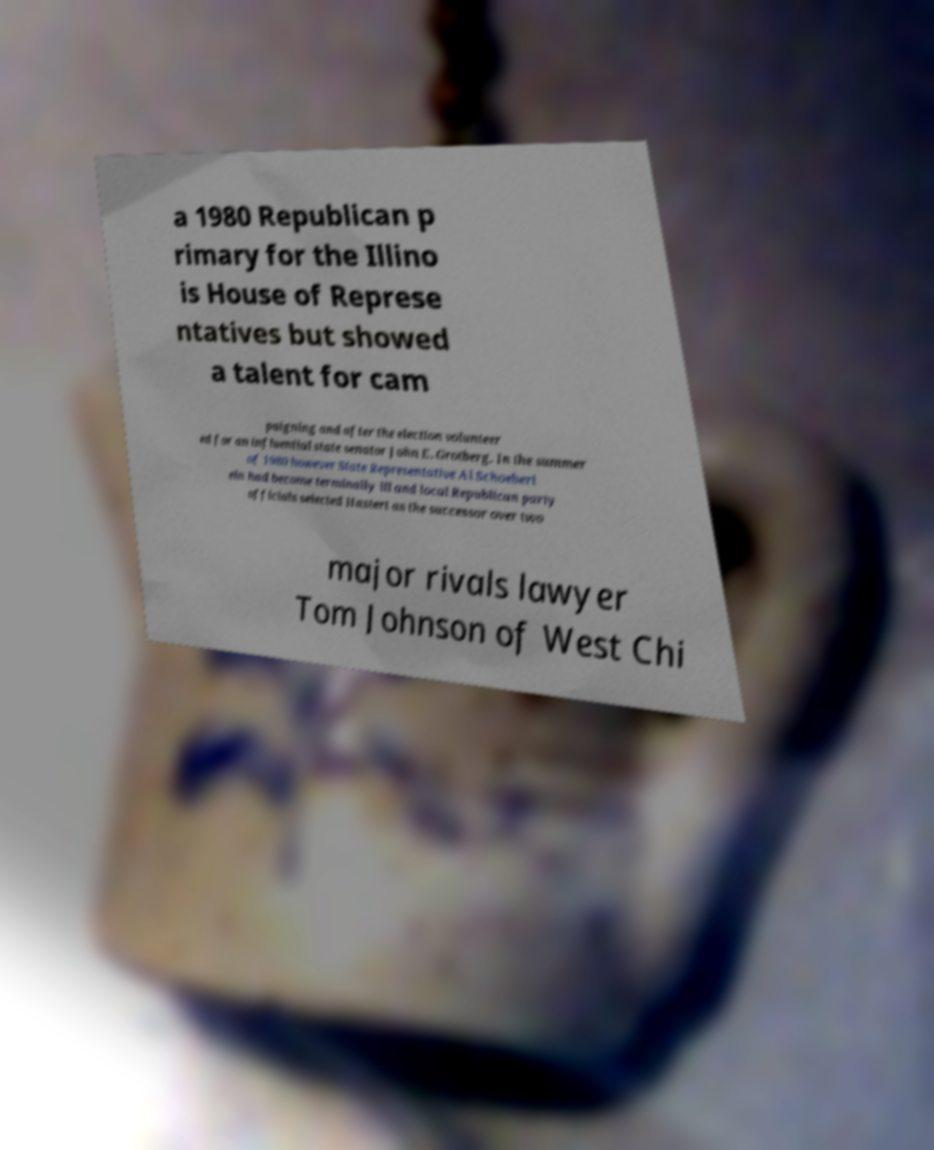I need the written content from this picture converted into text. Can you do that? a 1980 Republican p rimary for the Illino is House of Represe ntatives but showed a talent for cam paigning and after the election volunteer ed for an influential state senator John E. Grotberg. In the summer of 1980 however State Representative Al Schoeberi ein had become terminally ill and local Republican party officials selected Hastert as the successor over two major rivals lawyer Tom Johnson of West Chi 